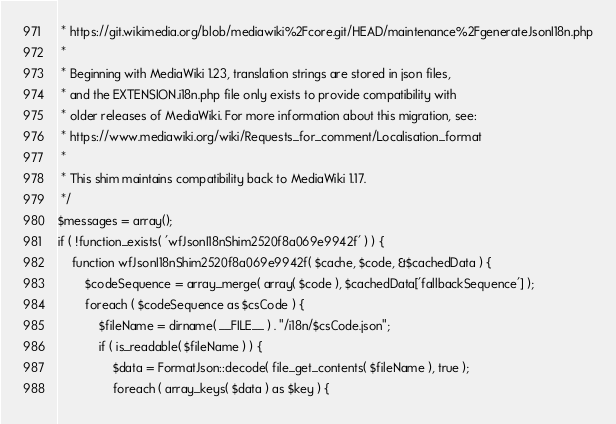Convert code to text. <code><loc_0><loc_0><loc_500><loc_500><_PHP_> * https://git.wikimedia.org/blob/mediawiki%2Fcore.git/HEAD/maintenance%2FgenerateJsonI18n.php
 *
 * Beginning with MediaWiki 1.23, translation strings are stored in json files,
 * and the EXTENSION.i18n.php file only exists to provide compatibility with
 * older releases of MediaWiki. For more information about this migration, see:
 * https://www.mediawiki.org/wiki/Requests_for_comment/Localisation_format
 *
 * This shim maintains compatibility back to MediaWiki 1.17.
 */
$messages = array();
if ( !function_exists( 'wfJsonI18nShim2520f8a069e9942f' ) ) {
	function wfJsonI18nShim2520f8a069e9942f( $cache, $code, &$cachedData ) {
		$codeSequence = array_merge( array( $code ), $cachedData['fallbackSequence'] );
		foreach ( $codeSequence as $csCode ) {
			$fileName = dirname( __FILE__ ) . "/i18n/$csCode.json";
			if ( is_readable( $fileName ) ) {
				$data = FormatJson::decode( file_get_contents( $fileName ), true );
				foreach ( array_keys( $data ) as $key ) {</code> 